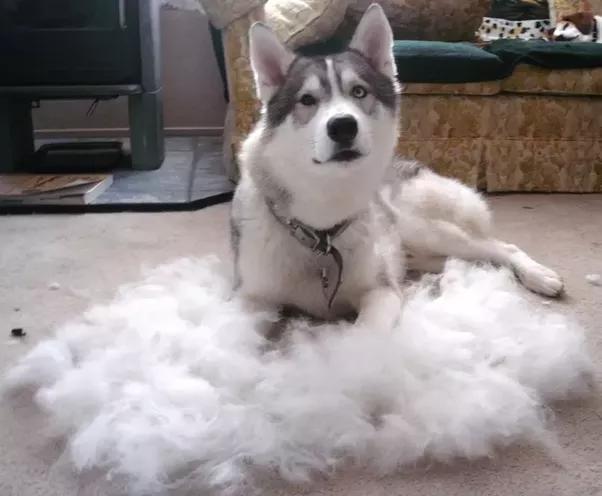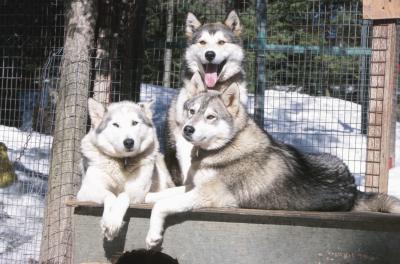The first image is the image on the left, the second image is the image on the right. For the images displayed, is the sentence "Four or more dogs can be seen." factually correct? Answer yes or no. Yes. The first image is the image on the left, the second image is the image on the right. Considering the images on both sides, is "There is freshly cut hair on the ground." valid? Answer yes or no. Yes. 